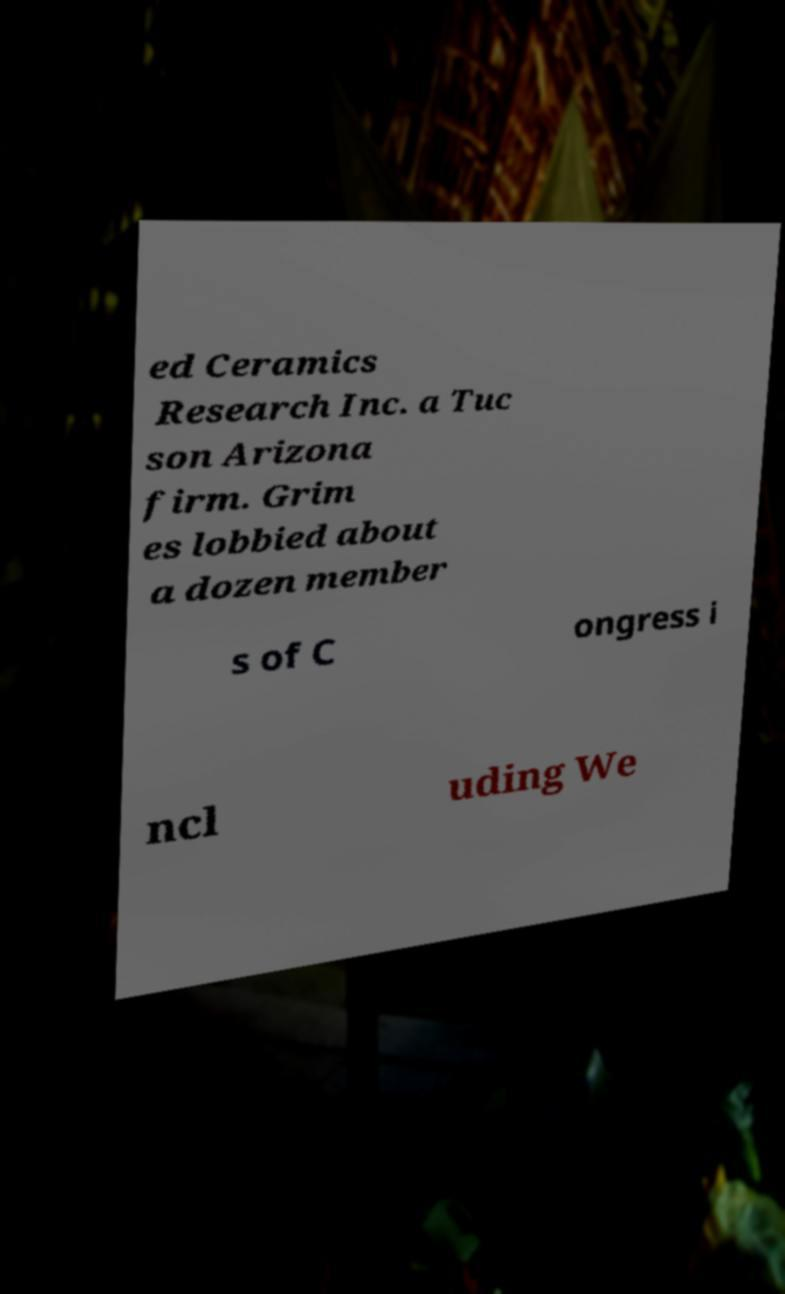Please identify and transcribe the text found in this image. ed Ceramics Research Inc. a Tuc son Arizona firm. Grim es lobbied about a dozen member s of C ongress i ncl uding We 